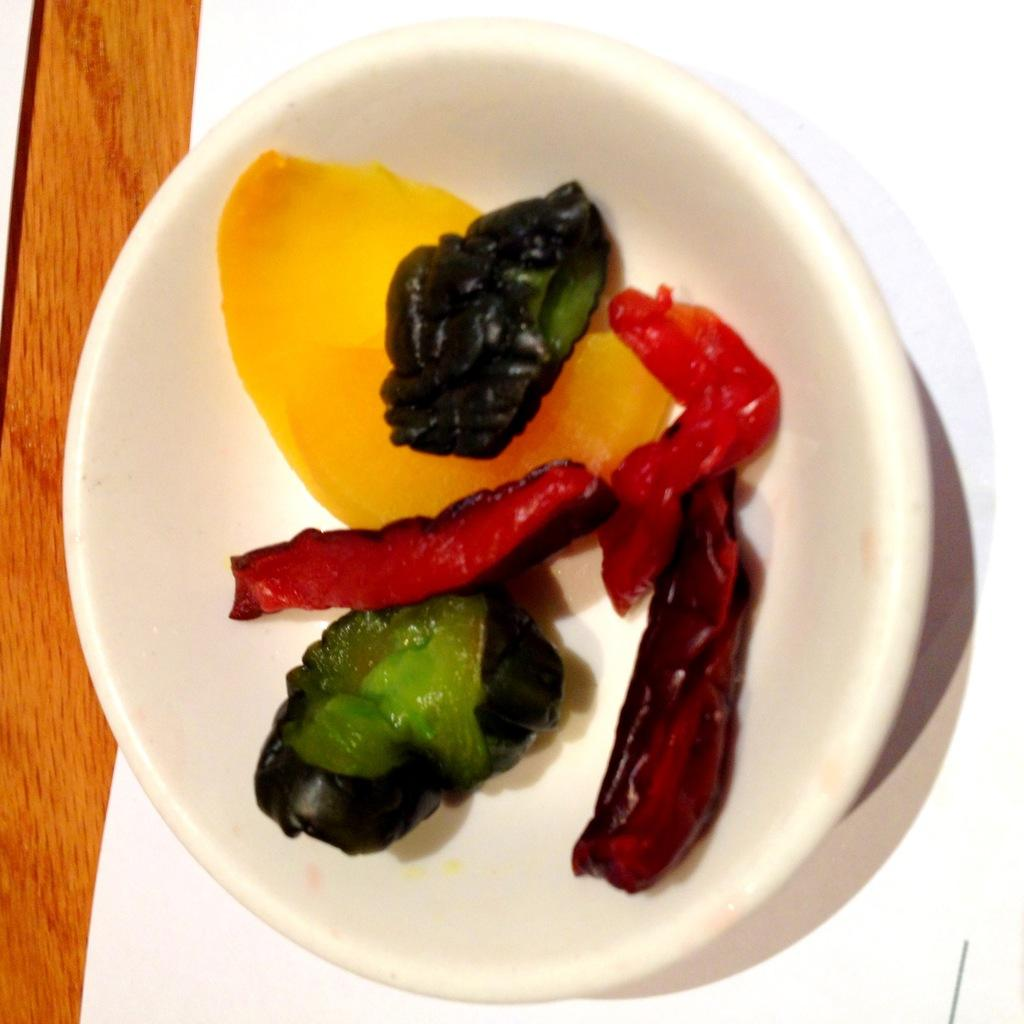What color is the bowl in the image? The bowl in the image is white. What is inside the bowl? The bowl contains food. Where is the bowl located? The bowl is placed on a table. What else is on the table besides the bowl? There is a white paper on the table. What type of berry is being examined by the doctor in the image? There is no doctor or berry present in the image. 